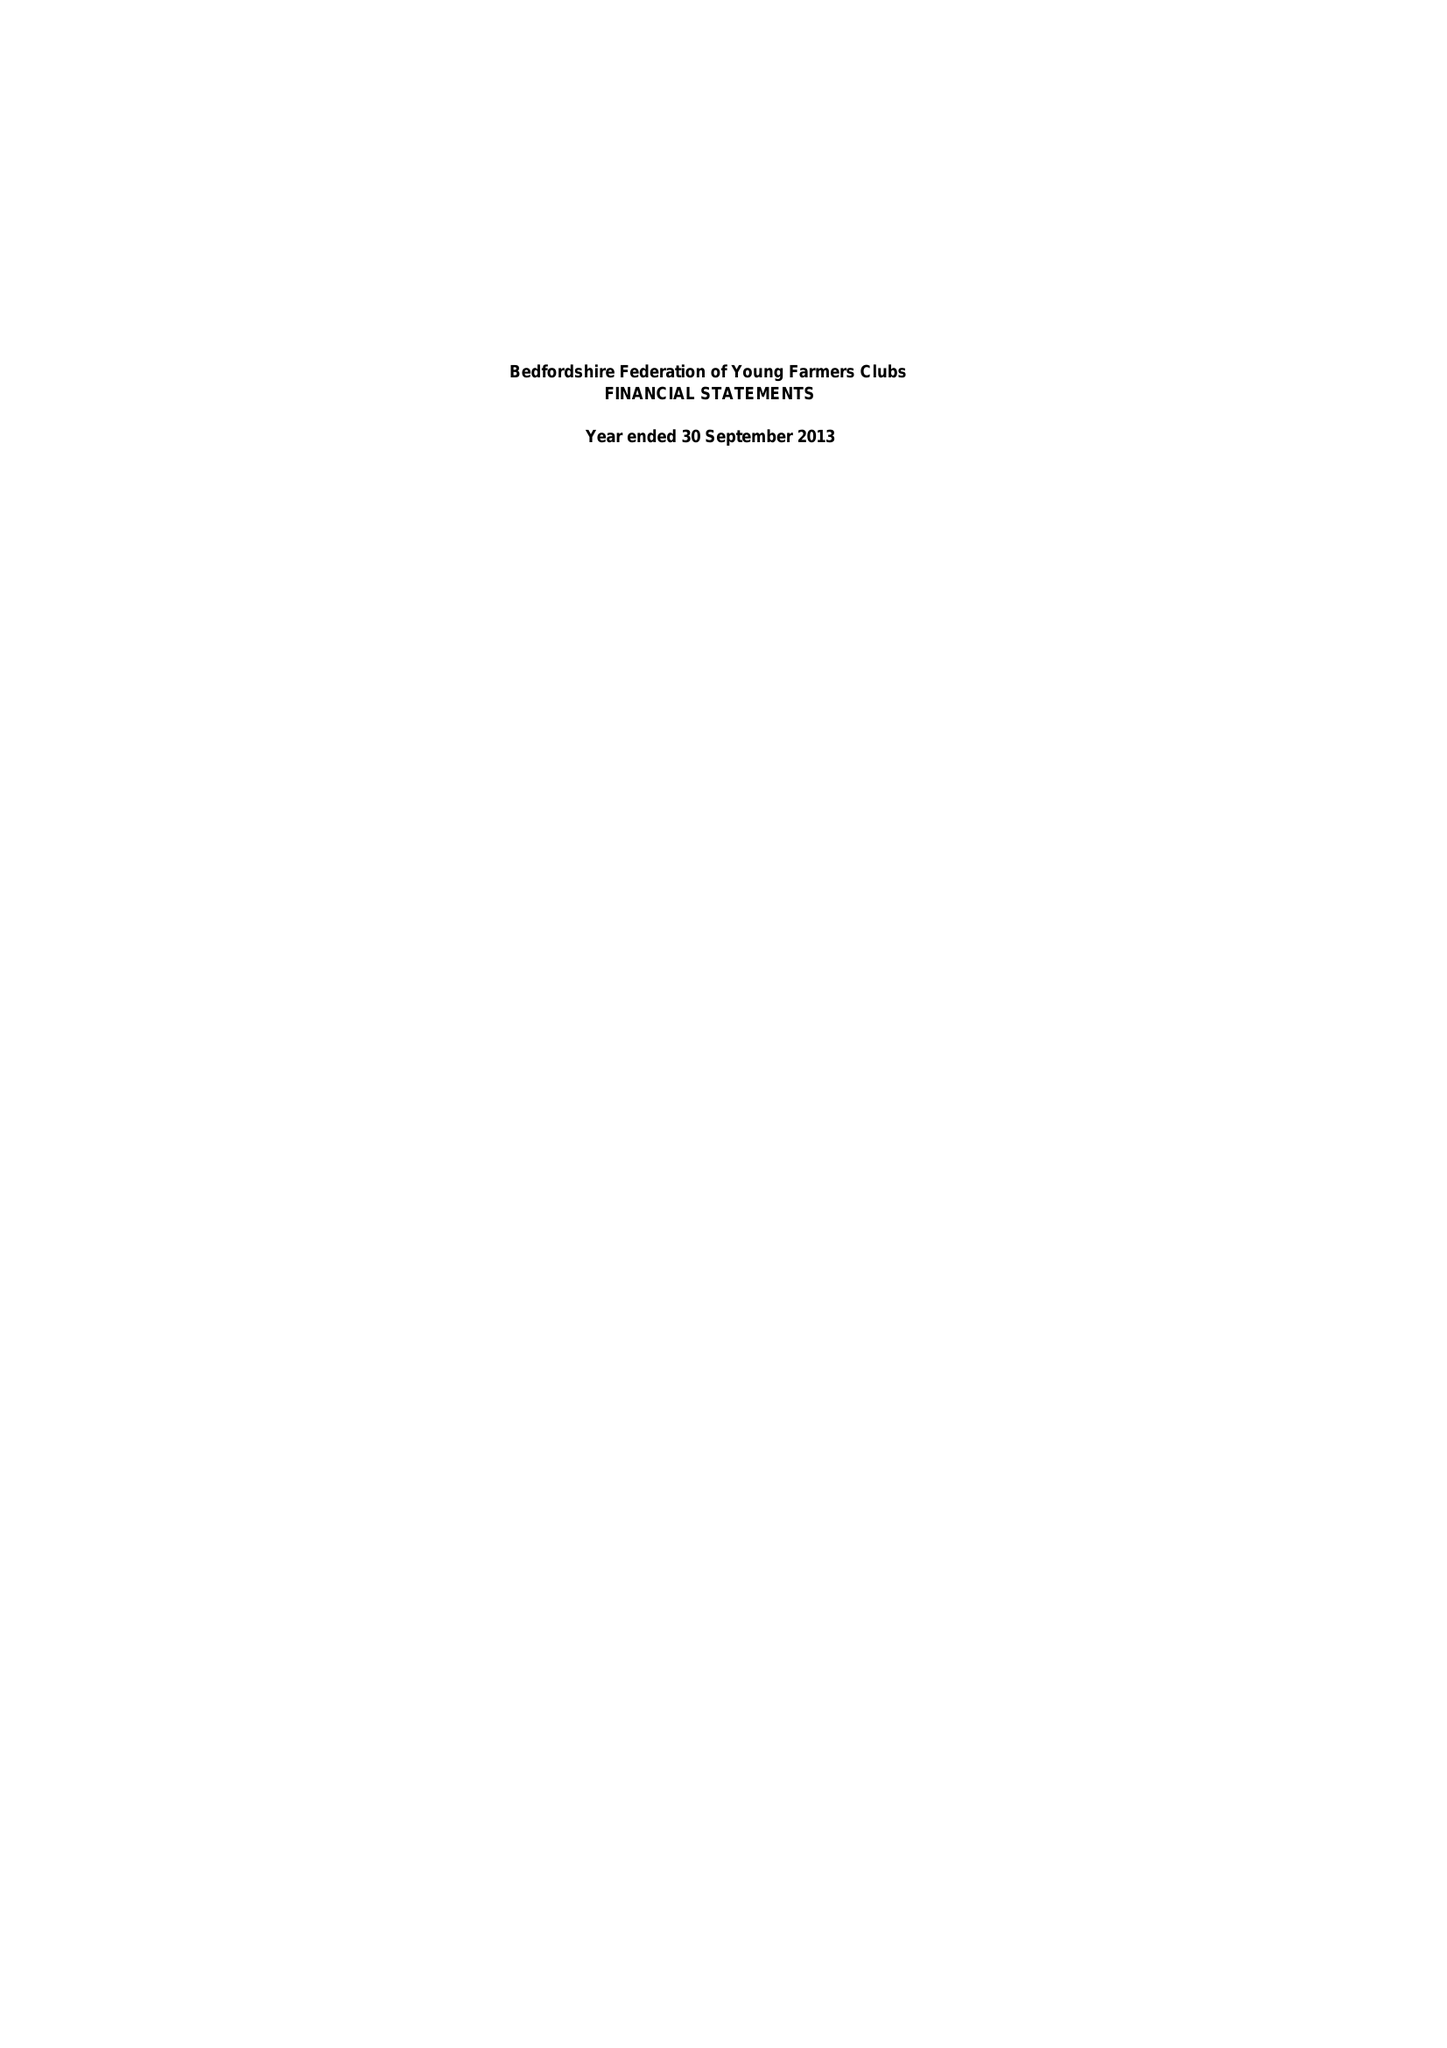What is the value for the spending_annually_in_british_pounds?
Answer the question using a single word or phrase. 51437.09 